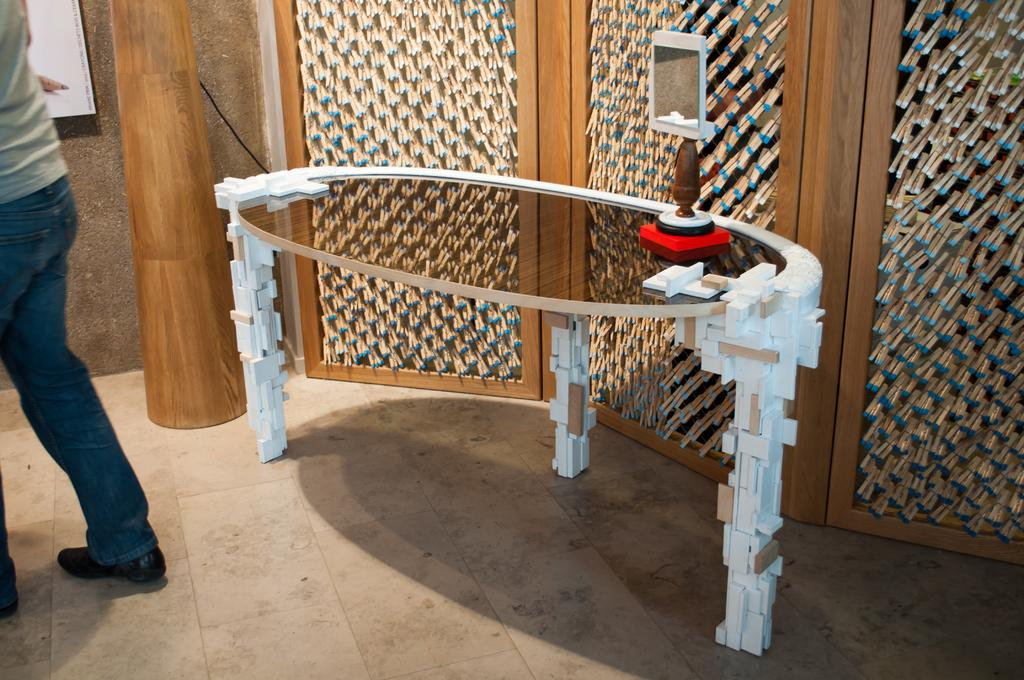What type of table is in the image? There is a glass table in the image. What object is placed on the table? There is a mirror on the table. Where is the man positioned in the image? The man is standing to the left side of the image. What can be seen in the background of the image? There is a pillar and a wall visible in the background of the image. What type of beast can be seen in the image? There is no beast present in the image. Is the man holding a camera in the image? There is no camera visible in the image. 